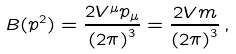<formula> <loc_0><loc_0><loc_500><loc_500>B ( p ^ { 2 } ) = \frac { 2 V ^ { \mu } p _ { \mu } } { { ( 2 \pi ) } ^ { 3 } } = \frac { 2 V m } { { ( 2 \pi ) } ^ { 3 } } \, ,</formula> 